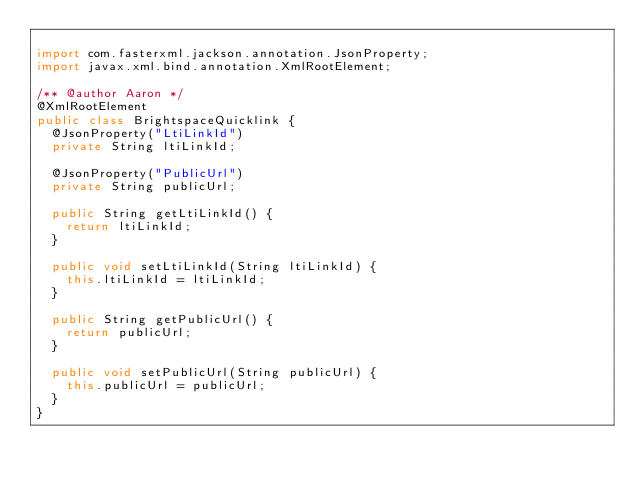<code> <loc_0><loc_0><loc_500><loc_500><_Java_>
import com.fasterxml.jackson.annotation.JsonProperty;
import javax.xml.bind.annotation.XmlRootElement;

/** @author Aaron */
@XmlRootElement
public class BrightspaceQuicklink {
  @JsonProperty("LtiLinkId")
  private String ltiLinkId;

  @JsonProperty("PublicUrl")
  private String publicUrl;

  public String getLtiLinkId() {
    return ltiLinkId;
  }

  public void setLtiLinkId(String ltiLinkId) {
    this.ltiLinkId = ltiLinkId;
  }

  public String getPublicUrl() {
    return publicUrl;
  }

  public void setPublicUrl(String publicUrl) {
    this.publicUrl = publicUrl;
  }
}
</code> 